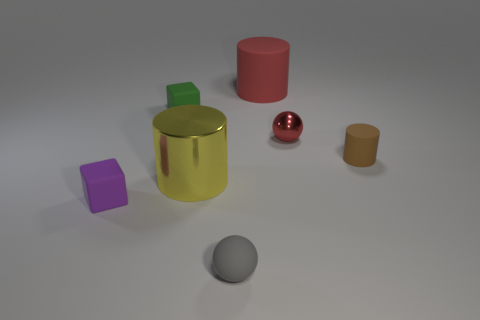How many things are either small green metal blocks or small matte balls?
Make the answer very short. 1. What number of other things are the same color as the big matte object?
Provide a succinct answer. 1. There is a purple object that is the same size as the gray thing; what shape is it?
Provide a succinct answer. Cube. Is there a small green matte object that has the same shape as the purple thing?
Your answer should be very brief. Yes. How many small green objects have the same material as the tiny red object?
Offer a terse response. 0. Are the tiny ball in front of the tiny purple object and the tiny purple object made of the same material?
Make the answer very short. Yes. Is the number of small matte objects that are behind the yellow metallic cylinder greater than the number of tiny red shiny spheres on the left side of the big red matte cylinder?
Provide a short and direct response. Yes. What material is the red ball that is the same size as the gray rubber sphere?
Provide a succinct answer. Metal. How many other things are the same material as the purple object?
Your answer should be very brief. 4. There is a tiny gray matte thing on the right side of the large metallic cylinder; is its shape the same as the red object in front of the big red cylinder?
Ensure brevity in your answer.  Yes. 